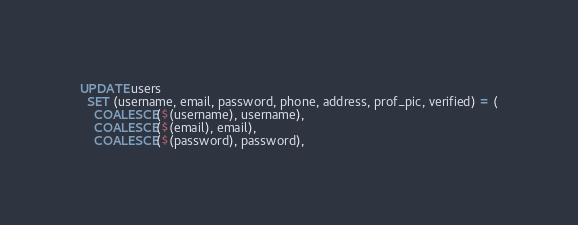<code> <loc_0><loc_0><loc_500><loc_500><_SQL_>UPDATE users
  SET (username, email, password, phone, address, prof_pic, verified) = (
    COALESCE($(username), username),
    COALESCE($(email), email),
    COALESCE($(password), password),</code> 